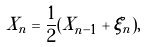Convert formula to latex. <formula><loc_0><loc_0><loc_500><loc_500>X _ { n } = \frac { 1 } { 2 } ( X _ { n - 1 } + \xi _ { n } ) ,</formula> 